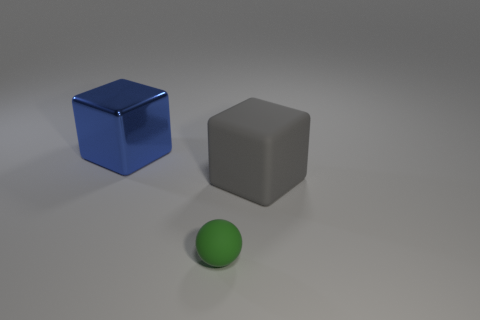What materials do the objects in the image seem to be made from? The cube appears to have a reflective surface that could suggest a metallic finish, the gray cube seems like a matte material such as plastic, and the green sphere has a diffuse surface that could be rubber or matte painted wood. 